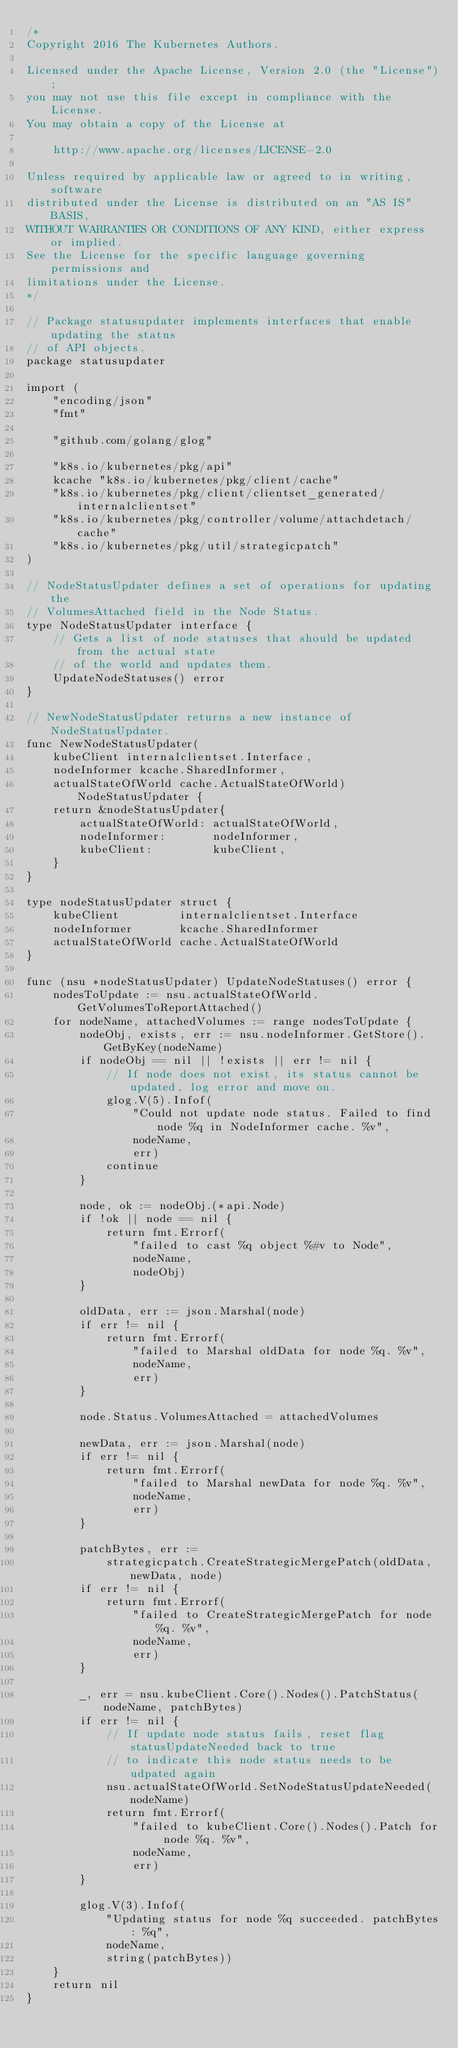<code> <loc_0><loc_0><loc_500><loc_500><_Go_>/*
Copyright 2016 The Kubernetes Authors.

Licensed under the Apache License, Version 2.0 (the "License");
you may not use this file except in compliance with the License.
You may obtain a copy of the License at

    http://www.apache.org/licenses/LICENSE-2.0

Unless required by applicable law or agreed to in writing, software
distributed under the License is distributed on an "AS IS" BASIS,
WITHOUT WARRANTIES OR CONDITIONS OF ANY KIND, either express or implied.
See the License for the specific language governing permissions and
limitations under the License.
*/

// Package statusupdater implements interfaces that enable updating the status
// of API objects.
package statusupdater

import (
	"encoding/json"
	"fmt"

	"github.com/golang/glog"

	"k8s.io/kubernetes/pkg/api"
	kcache "k8s.io/kubernetes/pkg/client/cache"
	"k8s.io/kubernetes/pkg/client/clientset_generated/internalclientset"
	"k8s.io/kubernetes/pkg/controller/volume/attachdetach/cache"
	"k8s.io/kubernetes/pkg/util/strategicpatch"
)

// NodeStatusUpdater defines a set of operations for updating the
// VolumesAttached field in the Node Status.
type NodeStatusUpdater interface {
	// Gets a list of node statuses that should be updated from the actual state
	// of the world and updates them.
	UpdateNodeStatuses() error
}

// NewNodeStatusUpdater returns a new instance of NodeStatusUpdater.
func NewNodeStatusUpdater(
	kubeClient internalclientset.Interface,
	nodeInformer kcache.SharedInformer,
	actualStateOfWorld cache.ActualStateOfWorld) NodeStatusUpdater {
	return &nodeStatusUpdater{
		actualStateOfWorld: actualStateOfWorld,
		nodeInformer:       nodeInformer,
		kubeClient:         kubeClient,
	}
}

type nodeStatusUpdater struct {
	kubeClient         internalclientset.Interface
	nodeInformer       kcache.SharedInformer
	actualStateOfWorld cache.ActualStateOfWorld
}

func (nsu *nodeStatusUpdater) UpdateNodeStatuses() error {
	nodesToUpdate := nsu.actualStateOfWorld.GetVolumesToReportAttached()
	for nodeName, attachedVolumes := range nodesToUpdate {
		nodeObj, exists, err := nsu.nodeInformer.GetStore().GetByKey(nodeName)
		if nodeObj == nil || !exists || err != nil {
			// If node does not exist, its status cannot be updated, log error and move on.
			glog.V(5).Infof(
				"Could not update node status. Failed to find node %q in NodeInformer cache. %v",
				nodeName,
				err)
			continue
		}

		node, ok := nodeObj.(*api.Node)
		if !ok || node == nil {
			return fmt.Errorf(
				"failed to cast %q object %#v to Node",
				nodeName,
				nodeObj)
		}

		oldData, err := json.Marshal(node)
		if err != nil {
			return fmt.Errorf(
				"failed to Marshal oldData for node %q. %v",
				nodeName,
				err)
		}

		node.Status.VolumesAttached = attachedVolumes

		newData, err := json.Marshal(node)
		if err != nil {
			return fmt.Errorf(
				"failed to Marshal newData for node %q. %v",
				nodeName,
				err)
		}

		patchBytes, err :=
			strategicpatch.CreateStrategicMergePatch(oldData, newData, node)
		if err != nil {
			return fmt.Errorf(
				"failed to CreateStrategicMergePatch for node %q. %v",
				nodeName,
				err)
		}

		_, err = nsu.kubeClient.Core().Nodes().PatchStatus(nodeName, patchBytes)
		if err != nil {
			// If update node status fails, reset flag statusUpdateNeeded back to true
			// to indicate this node status needs to be udpated again
			nsu.actualStateOfWorld.SetNodeStatusUpdateNeeded(nodeName)
			return fmt.Errorf(
				"failed to kubeClient.Core().Nodes().Patch for node %q. %v",
				nodeName,
				err)
		}

		glog.V(3).Infof(
			"Updating status for node %q succeeded. patchBytes: %q",
			nodeName,
			string(patchBytes))
	}
	return nil
}
</code> 